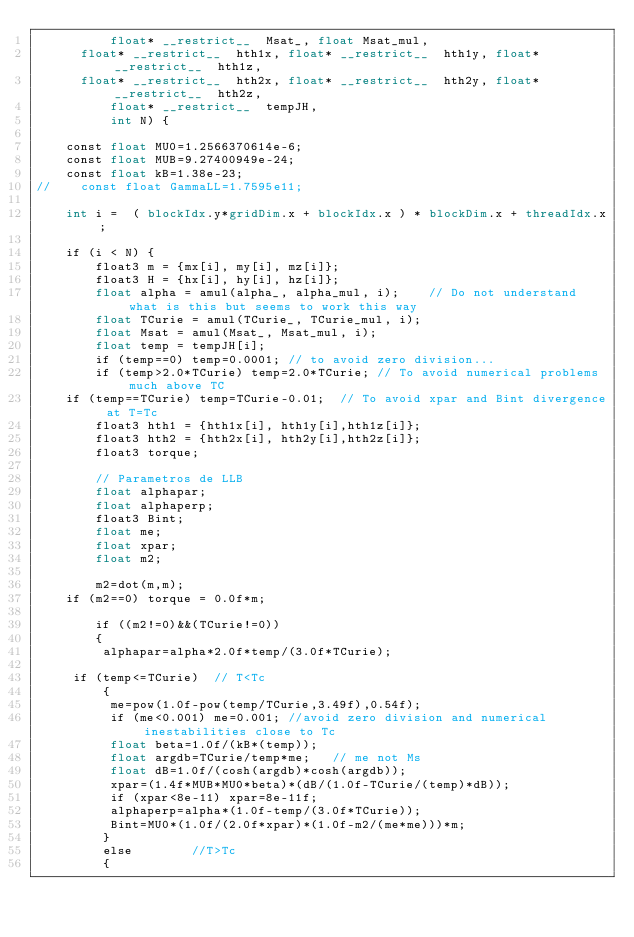Convert code to text. <code><loc_0><loc_0><loc_500><loc_500><_Cuda_>          float* __restrict__  Msat_, float Msat_mul,
	  float* __restrict__  hth1x, float* __restrict__  hth1y, float* __restrict__  hth1z,
	  float* __restrict__  hth2x, float* __restrict__  hth2y, float* __restrict__  hth2z,
          float* __restrict__  tempJH,
          int N) {

    const float MU0=1.2566370614e-6;
    const float MUB=9.27400949e-24;
    const float kB=1.38e-23;
//    const float GammaLL=1.7595e11;
  
    int i =  ( blockIdx.y*gridDim.x + blockIdx.x ) * blockDim.x + threadIdx.x;

    if (i < N) {
        float3 m = {mx[i], my[i], mz[i]};
        float3 H = {hx[i], hy[i], hz[i]};
        float alpha = amul(alpha_, alpha_mul, i);    // Do not understand what is this but seems to work this way
        float TCurie = amul(TCurie_, TCurie_mul, i);
        float Msat = amul(Msat_, Msat_mul, i);
        float temp = tempJH[i]; 
        if (temp==0) temp=0.0001; // to avoid zero division...
        if (temp>2.0*TCurie) temp=2.0*TCurie; // To avoid numerical problems much above TC
	if (temp==TCurie) temp=TCurie-0.01;  // To avoid xpar and Bint divergence at T=Tc
        float3 hth1 = {hth1x[i], hth1y[i],hth1z[i]};
        float3 hth2 = {hth2x[i], hth2y[i],hth2z[i]};
        float3 torque;

        // Parametros de LLB
        float alphapar;
        float alphaperp;
        float3 Bint;
        float me;
        float xpar;
        float m2;
	
        m2=dot(m,m);
	if (m2==0) torque = 0.0f*m;
 
        if ((m2!=0)&&(TCurie!=0))
        {
         alphapar=alpha*2.0f*temp/(3.0f*TCurie);
 	        
	 if (temp<=TCurie)  // T<Tc
         {
          me=pow(1.0f-pow(temp/TCurie,3.49f),0.54f);
          if (me<0.001) me=0.001; //avoid zero division and numerical inestabilities close to Tc
          float beta=1.0f/(kB*(temp));
          float argdb=TCurie/temp*me;   // me not Ms
          float dB=1.0f/(cosh(argdb)*cosh(argdb));
          xpar=(1.4f*MUB*MU0*beta)*(dB/(1.0f-TCurie/(temp)*dB));
          if (xpar<8e-11) xpar=8e-11f;
          alphaperp=alpha*(1.0f-temp/(3.0f*TCurie));
          Bint=MU0*(1.0f/(2.0f*xpar)*(1.0f-m2/(me*me)))*m;
         }
         else        //T>Tc
         {</code> 